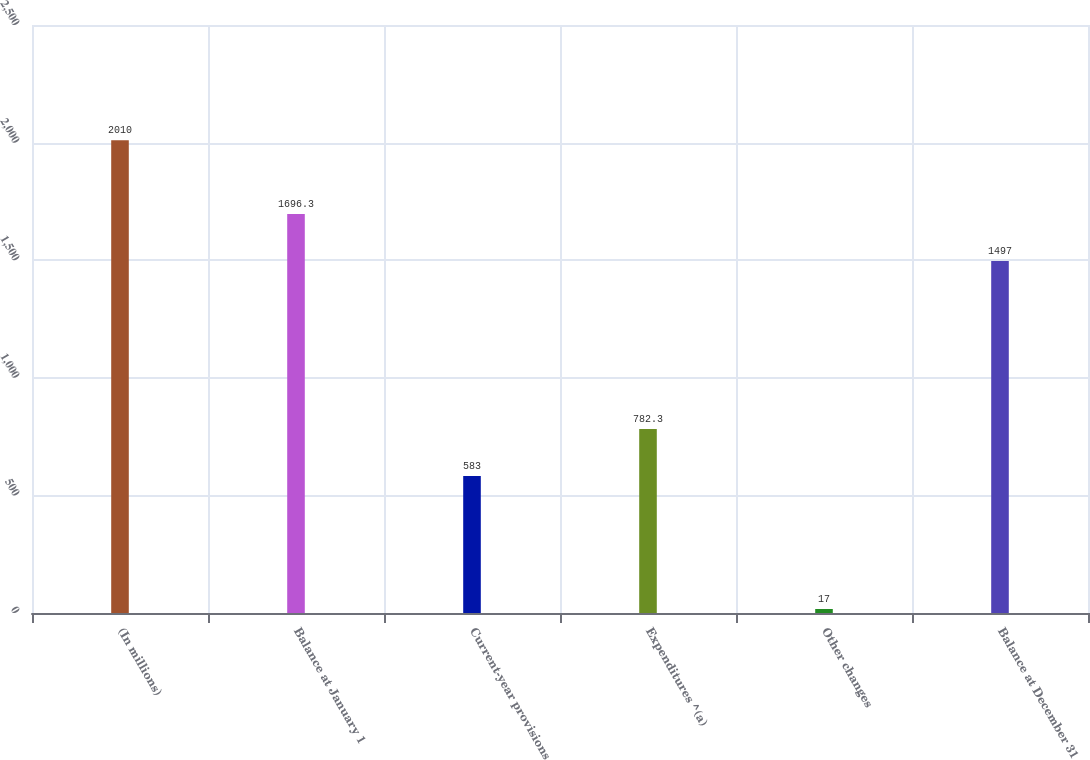Convert chart. <chart><loc_0><loc_0><loc_500><loc_500><bar_chart><fcel>(In millions)<fcel>Balance at January 1<fcel>Current-year provisions<fcel>Expenditures ^(a)<fcel>Other changes<fcel>Balance at December 31<nl><fcel>2010<fcel>1696.3<fcel>583<fcel>782.3<fcel>17<fcel>1497<nl></chart> 